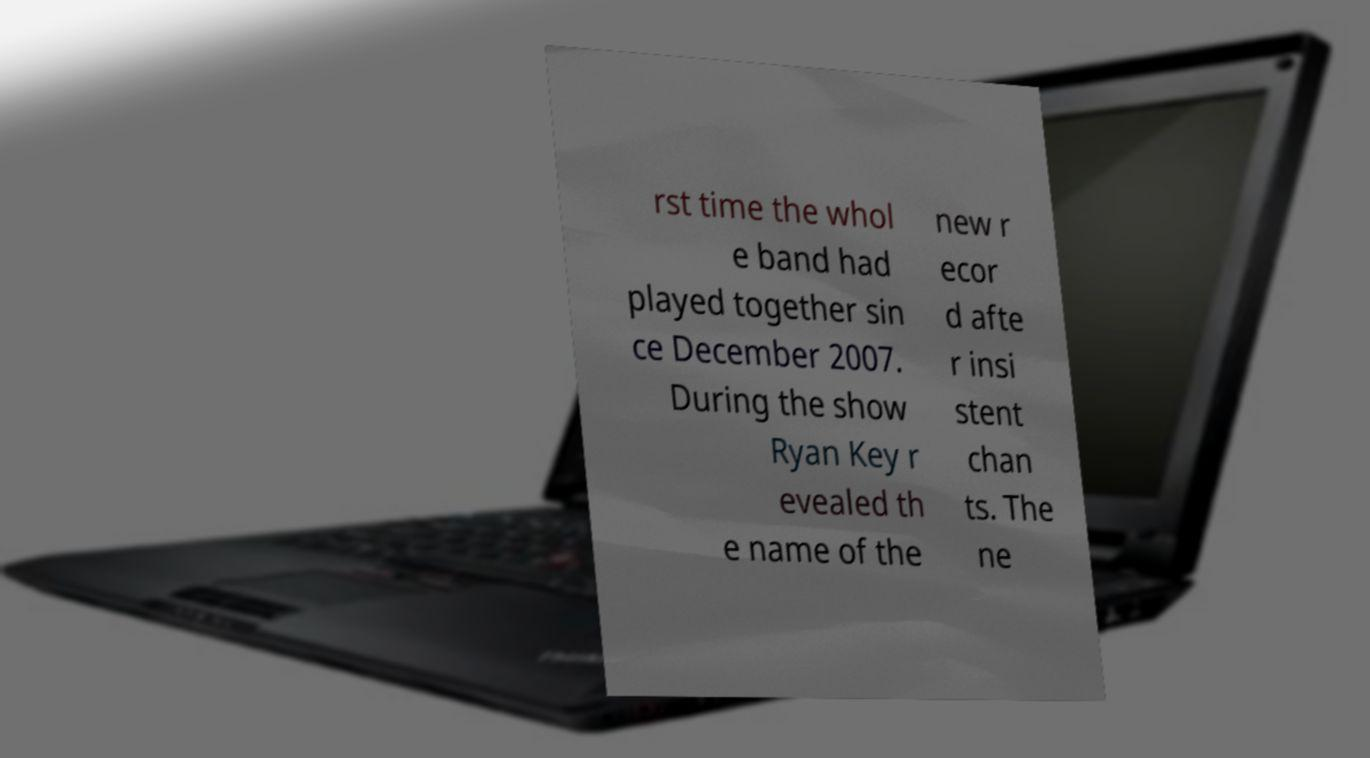I need the written content from this picture converted into text. Can you do that? rst time the whol e band had played together sin ce December 2007. During the show Ryan Key r evealed th e name of the new r ecor d afte r insi stent chan ts. The ne 